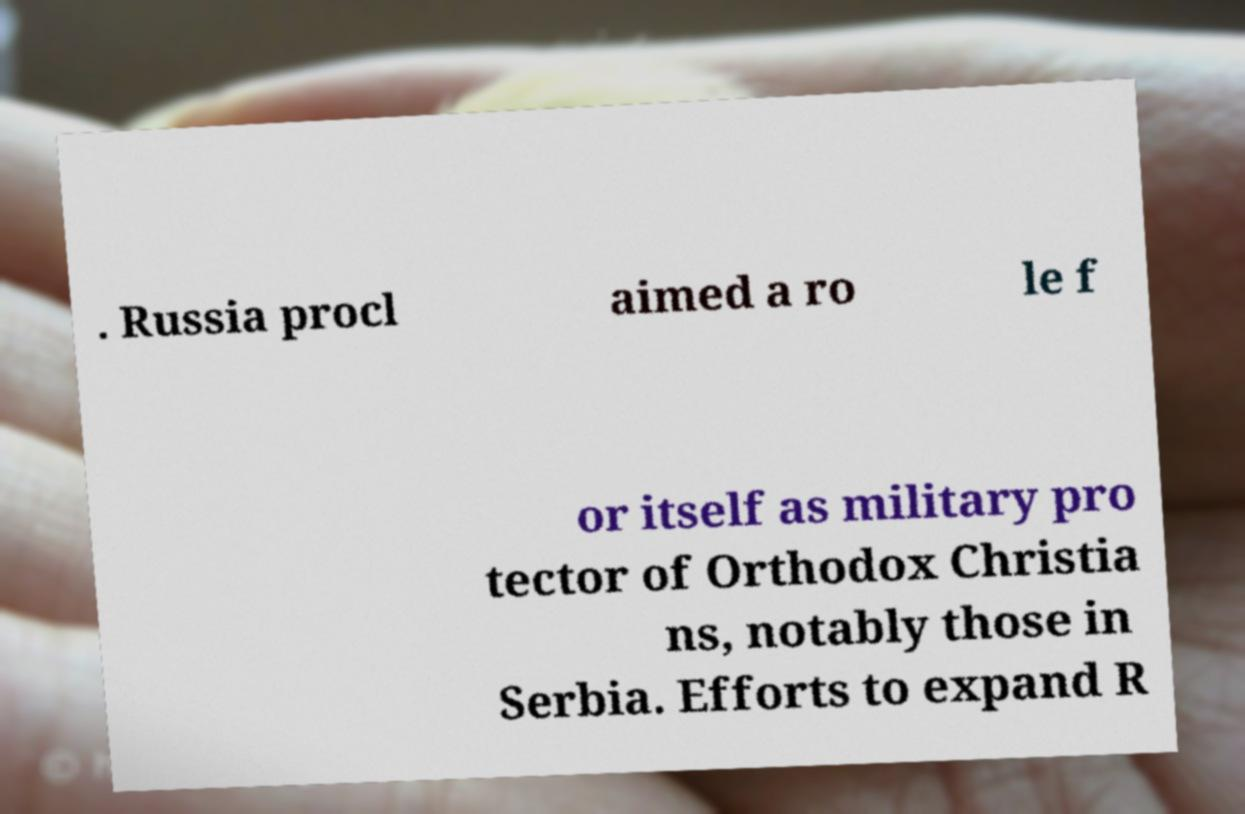I need the written content from this picture converted into text. Can you do that? . Russia procl aimed a ro le f or itself as military pro tector of Orthodox Christia ns, notably those in Serbia. Efforts to expand R 